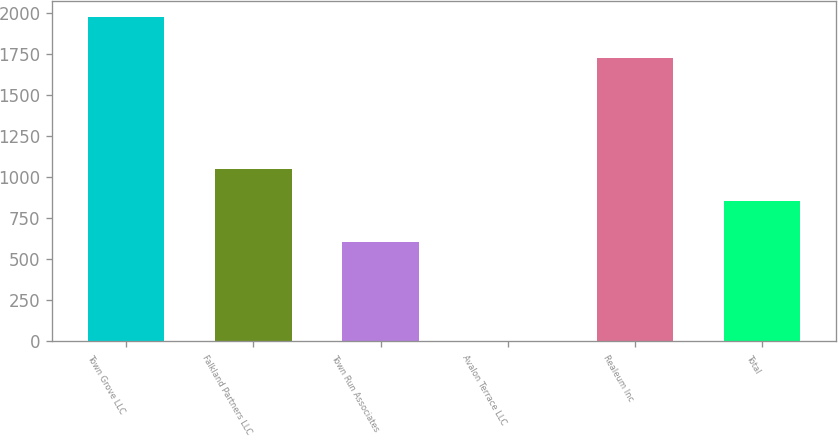<chart> <loc_0><loc_0><loc_500><loc_500><bar_chart><fcel>Town Grove LLC<fcel>Falkland Partners LLC<fcel>Town Run Associates<fcel>Avalon Terrace LLC<fcel>Realeum Inc<fcel>Total<nl><fcel>1977<fcel>1053.4<fcel>606<fcel>3<fcel>1730<fcel>856<nl></chart> 